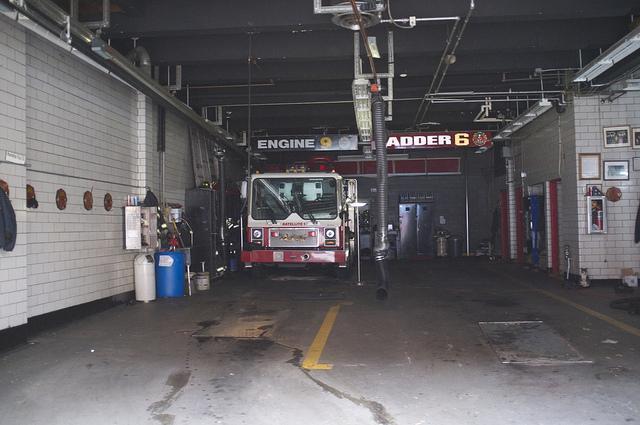How many trucks are in this garage?
Give a very brief answer. 1. 